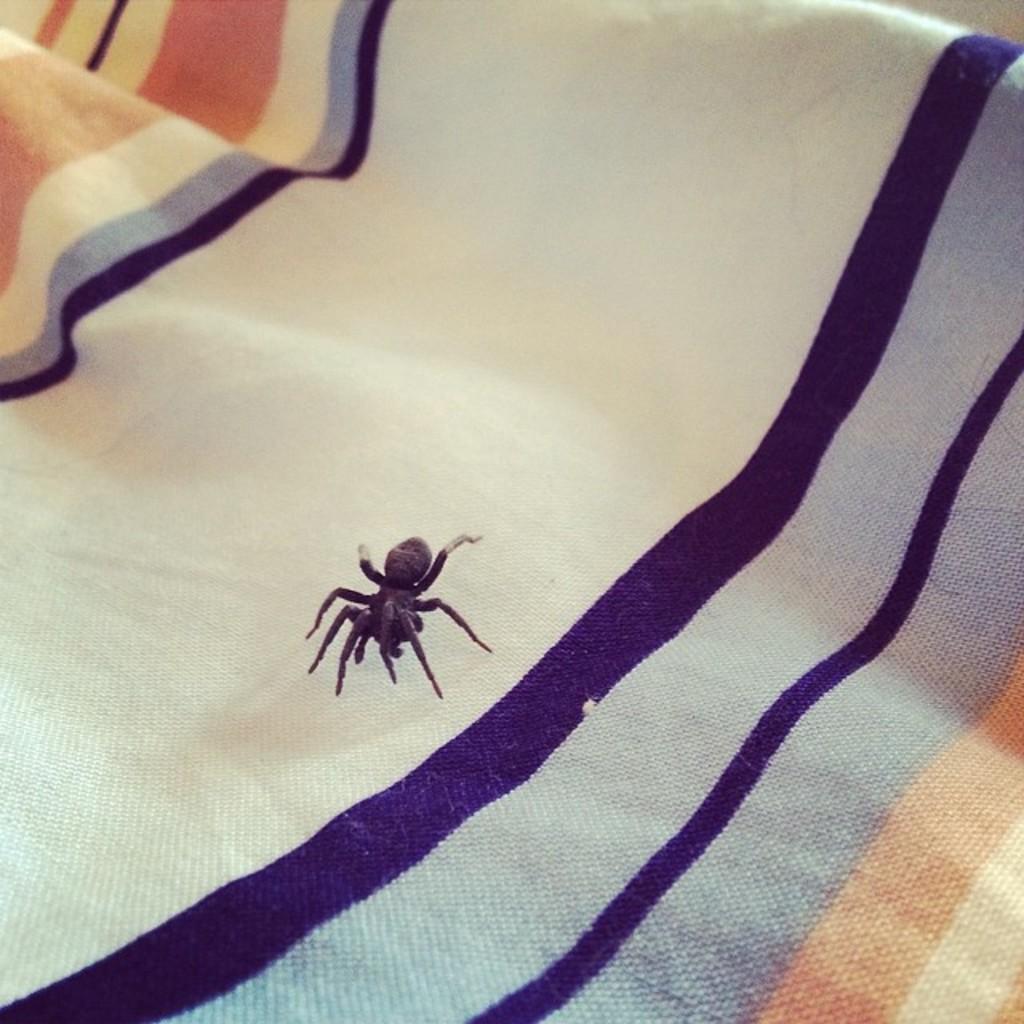Describe this image in one or two sentences. In the picture we can see a spider on the cloth. 